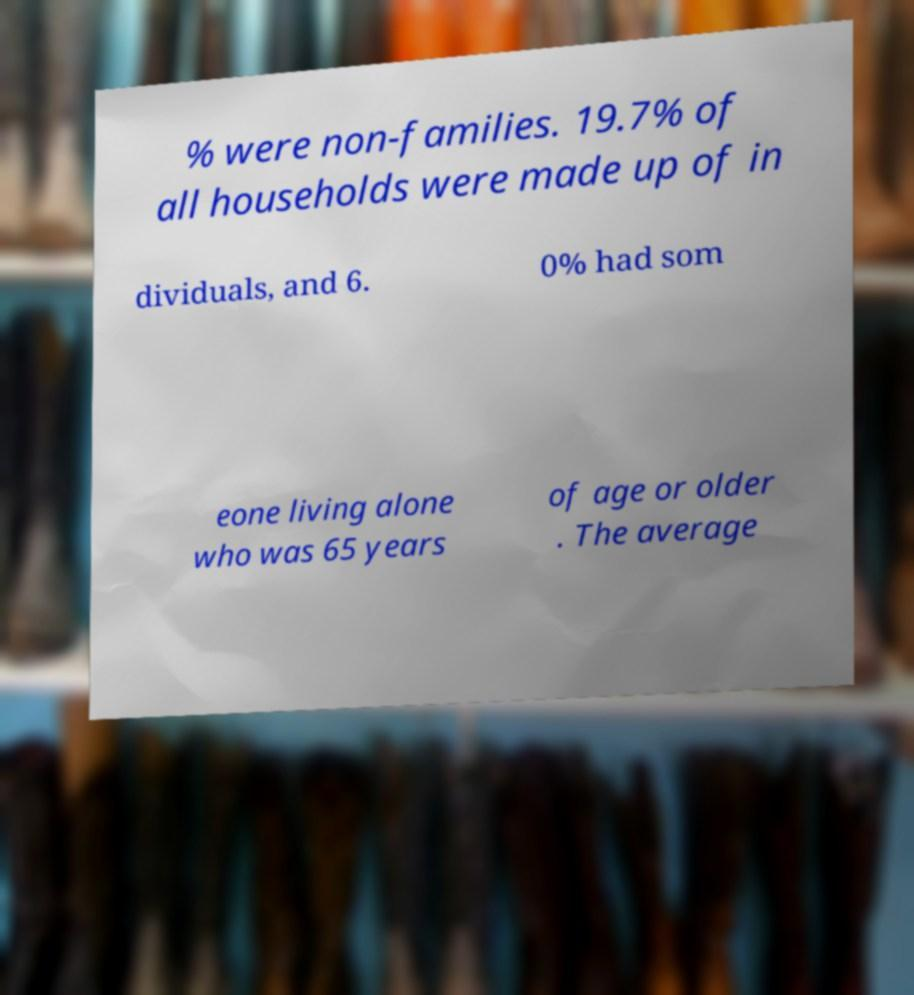For documentation purposes, I need the text within this image transcribed. Could you provide that? % were non-families. 19.7% of all households were made up of in dividuals, and 6. 0% had som eone living alone who was 65 years of age or older . The average 